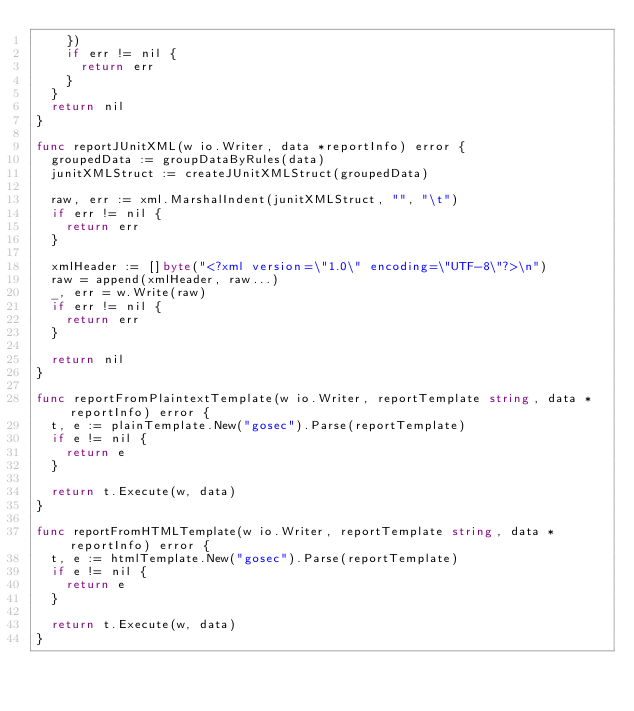<code> <loc_0><loc_0><loc_500><loc_500><_Go_>		})
		if err != nil {
			return err
		}
	}
	return nil
}

func reportJUnitXML(w io.Writer, data *reportInfo) error {
	groupedData := groupDataByRules(data)
	junitXMLStruct := createJUnitXMLStruct(groupedData)

	raw, err := xml.MarshalIndent(junitXMLStruct, "", "\t")
	if err != nil {
		return err
	}

	xmlHeader := []byte("<?xml version=\"1.0\" encoding=\"UTF-8\"?>\n")
	raw = append(xmlHeader, raw...)
	_, err = w.Write(raw)
	if err != nil {
		return err
	}

	return nil
}

func reportFromPlaintextTemplate(w io.Writer, reportTemplate string, data *reportInfo) error {
	t, e := plainTemplate.New("gosec").Parse(reportTemplate)
	if e != nil {
		return e
	}

	return t.Execute(w, data)
}

func reportFromHTMLTemplate(w io.Writer, reportTemplate string, data *reportInfo) error {
	t, e := htmlTemplate.New("gosec").Parse(reportTemplate)
	if e != nil {
		return e
	}

	return t.Execute(w, data)
}
</code> 